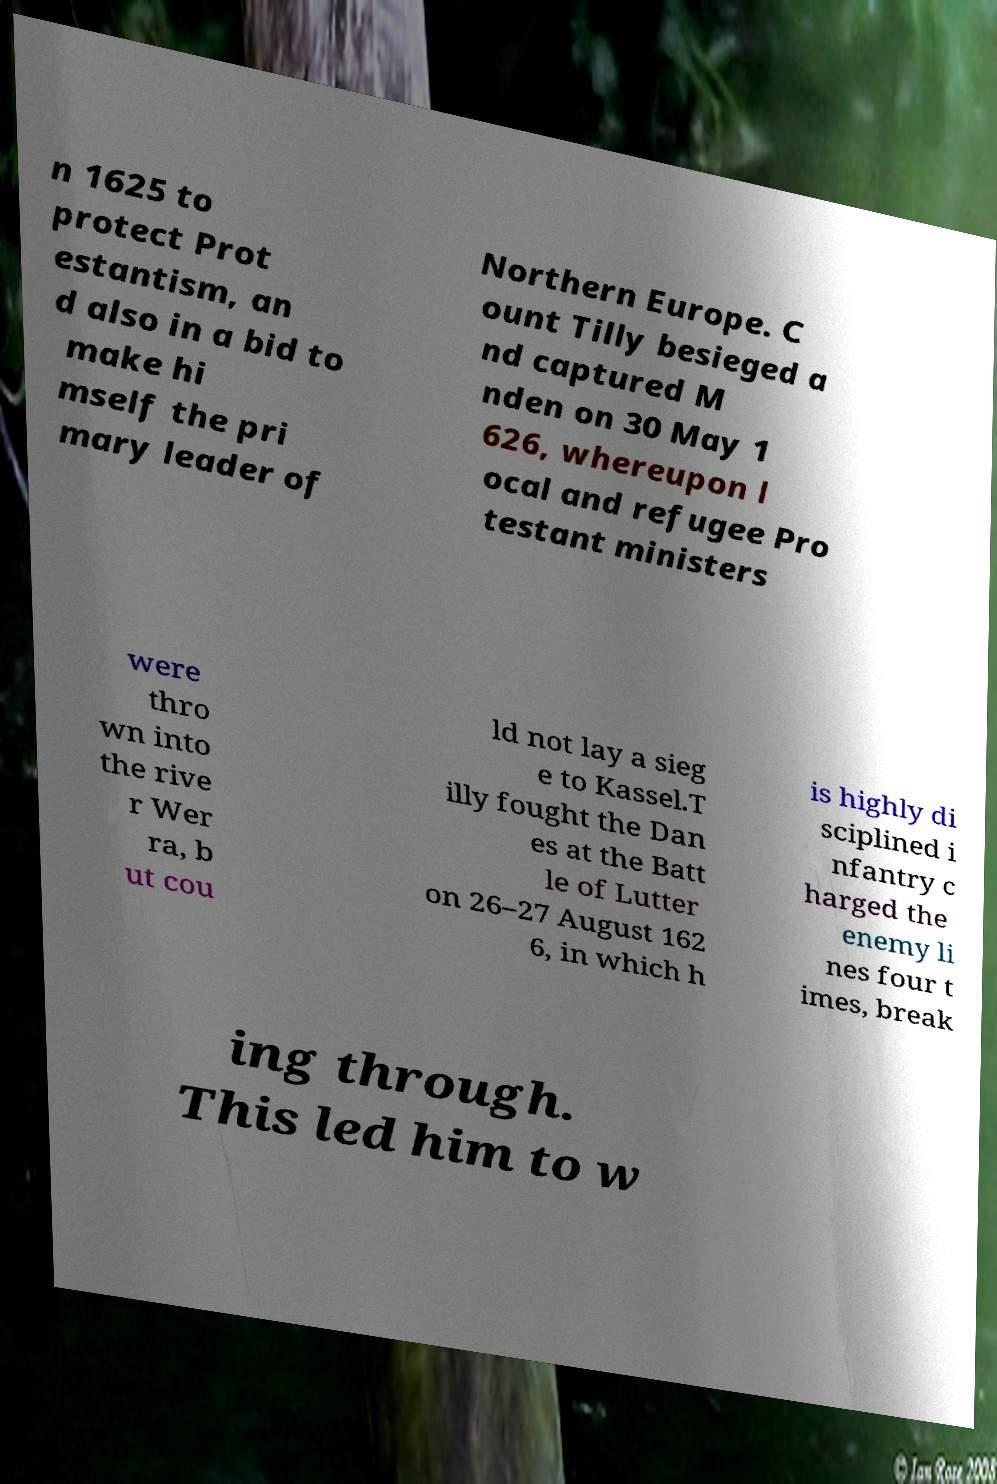I need the written content from this picture converted into text. Can you do that? n 1625 to protect Prot estantism, an d also in a bid to make hi mself the pri mary leader of Northern Europe. C ount Tilly besieged a nd captured M nden on 30 May 1 626, whereupon l ocal and refugee Pro testant ministers were thro wn into the rive r Wer ra, b ut cou ld not lay a sieg e to Kassel.T illy fought the Dan es at the Batt le of Lutter on 26–27 August 162 6, in which h is highly di sciplined i nfantry c harged the enemy li nes four t imes, break ing through. This led him to w 